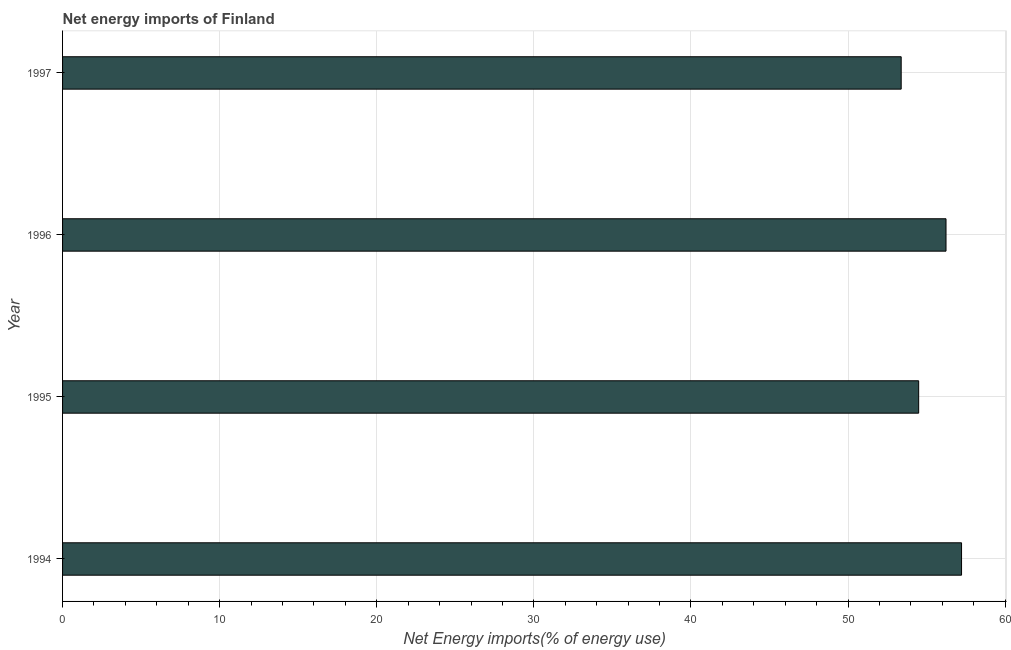What is the title of the graph?
Ensure brevity in your answer.  Net energy imports of Finland. What is the label or title of the X-axis?
Ensure brevity in your answer.  Net Energy imports(% of energy use). What is the energy imports in 1995?
Your response must be concise. 54.5. Across all years, what is the maximum energy imports?
Your answer should be compact. 57.23. Across all years, what is the minimum energy imports?
Your response must be concise. 53.38. What is the sum of the energy imports?
Your response must be concise. 221.34. What is the difference between the energy imports in 1994 and 1997?
Provide a short and direct response. 3.84. What is the average energy imports per year?
Your response must be concise. 55.34. What is the median energy imports?
Provide a short and direct response. 55.37. What is the ratio of the energy imports in 1994 to that in 1997?
Your response must be concise. 1.07. Is the energy imports in 1995 less than that in 1997?
Offer a very short reply. No. What is the difference between the highest and the second highest energy imports?
Offer a very short reply. 0.99. What is the difference between the highest and the lowest energy imports?
Provide a short and direct response. 3.84. In how many years, is the energy imports greater than the average energy imports taken over all years?
Make the answer very short. 2. What is the difference between two consecutive major ticks on the X-axis?
Provide a succinct answer. 10. Are the values on the major ticks of X-axis written in scientific E-notation?
Provide a succinct answer. No. What is the Net Energy imports(% of energy use) in 1994?
Keep it short and to the point. 57.23. What is the Net Energy imports(% of energy use) of 1995?
Give a very brief answer. 54.5. What is the Net Energy imports(% of energy use) in 1996?
Keep it short and to the point. 56.24. What is the Net Energy imports(% of energy use) in 1997?
Ensure brevity in your answer.  53.38. What is the difference between the Net Energy imports(% of energy use) in 1994 and 1995?
Make the answer very short. 2.73. What is the difference between the Net Energy imports(% of energy use) in 1994 and 1996?
Your answer should be compact. 0.99. What is the difference between the Net Energy imports(% of energy use) in 1994 and 1997?
Provide a short and direct response. 3.84. What is the difference between the Net Energy imports(% of energy use) in 1995 and 1996?
Your answer should be compact. -1.74. What is the difference between the Net Energy imports(% of energy use) in 1995 and 1997?
Make the answer very short. 1.11. What is the difference between the Net Energy imports(% of energy use) in 1996 and 1997?
Keep it short and to the point. 2.85. What is the ratio of the Net Energy imports(% of energy use) in 1994 to that in 1995?
Offer a very short reply. 1.05. What is the ratio of the Net Energy imports(% of energy use) in 1994 to that in 1996?
Ensure brevity in your answer.  1.02. What is the ratio of the Net Energy imports(% of energy use) in 1994 to that in 1997?
Offer a terse response. 1.07. What is the ratio of the Net Energy imports(% of energy use) in 1995 to that in 1996?
Ensure brevity in your answer.  0.97. What is the ratio of the Net Energy imports(% of energy use) in 1995 to that in 1997?
Provide a short and direct response. 1.02. What is the ratio of the Net Energy imports(% of energy use) in 1996 to that in 1997?
Provide a succinct answer. 1.05. 